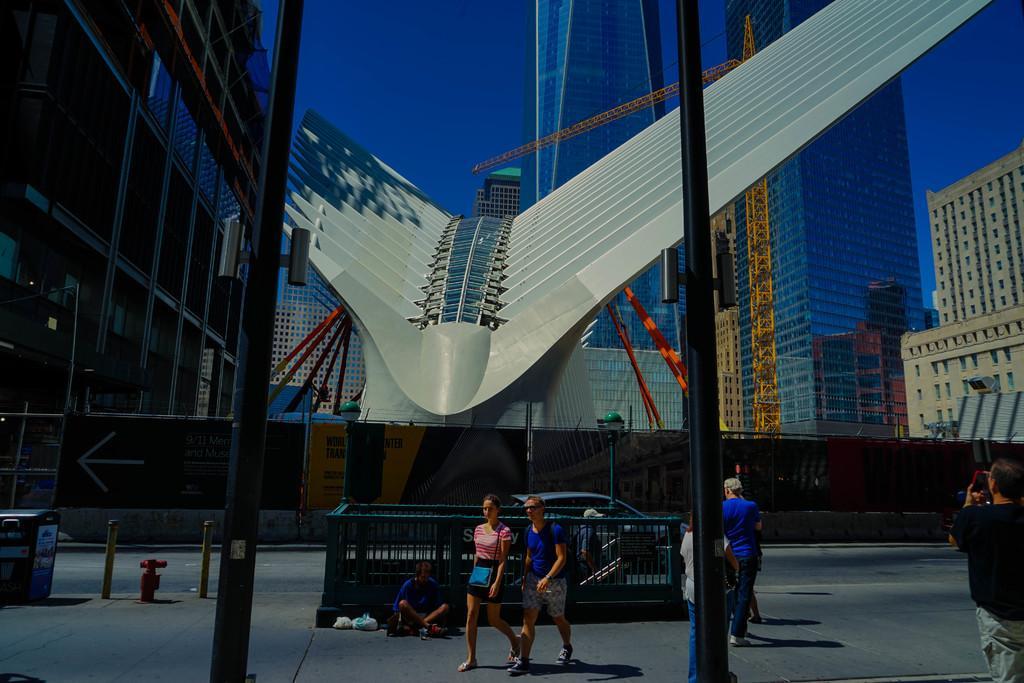Can you describe this image briefly? In the picture I can see these people are walking on the road, here I can see the staircase, a car moving on the road, we can see poles, tower buildings and the sky in the background. 